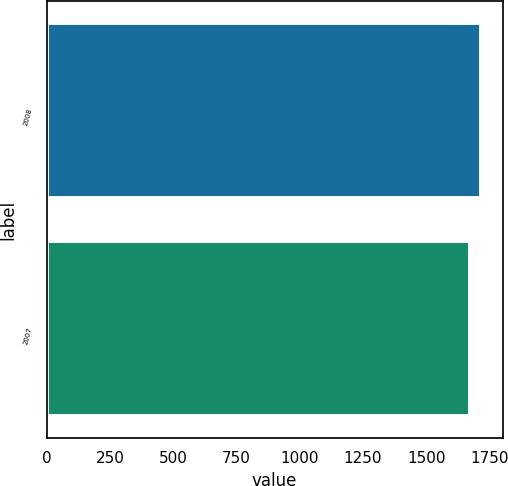Convert chart to OTSL. <chart><loc_0><loc_0><loc_500><loc_500><bar_chart><fcel>2008<fcel>2007<nl><fcel>1716<fcel>1672<nl></chart> 